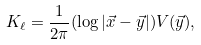Convert formula to latex. <formula><loc_0><loc_0><loc_500><loc_500>K _ { \ell } = \frac { 1 } { 2 \pi } ( \log | \vec { x } - \vec { y } | ) V ( \vec { y } ) ,</formula> 